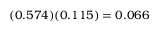Convert formula to latex. <formula><loc_0><loc_0><loc_500><loc_500>( 0 . 5 7 4 ) ( 0 . 1 1 5 ) = 0 . 0 6 6</formula> 